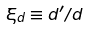Convert formula to latex. <formula><loc_0><loc_0><loc_500><loc_500>\xi _ { d } \equiv d ^ { \prime } / d</formula> 